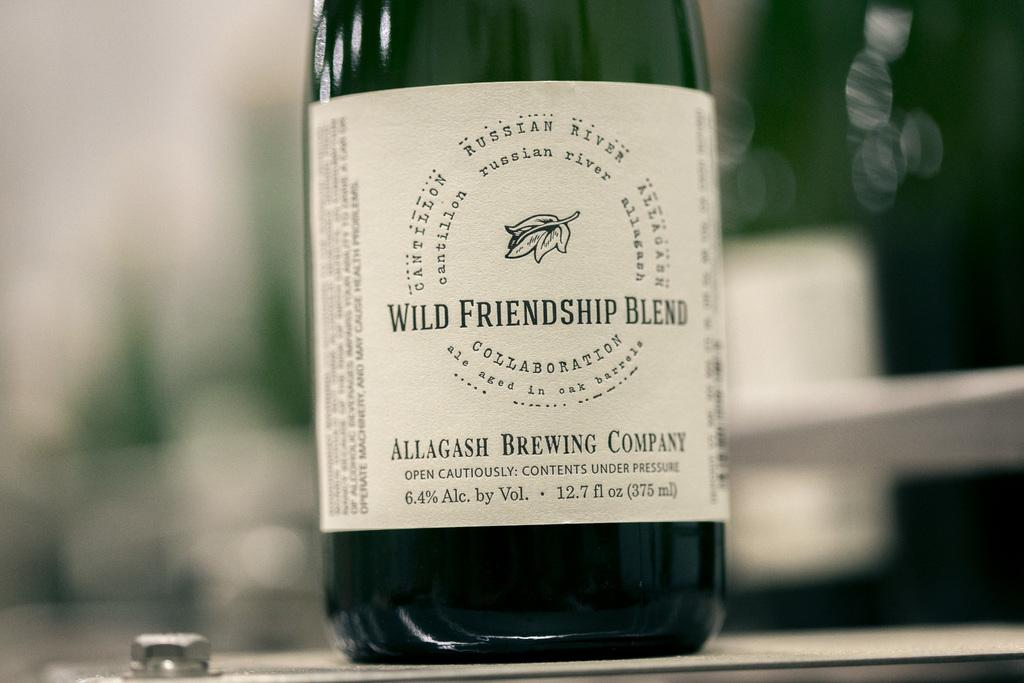<image>
Provide a brief description of the given image. bottle of wine called wild friendship blend sits un opened 